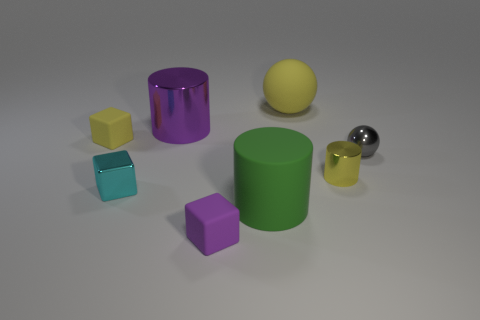Subtract all small cyan shiny cubes. How many cubes are left? 2 Subtract 1 cylinders. How many cylinders are left? 2 Subtract all purple cylinders. How many cylinders are left? 2 Subtract all brown cylinders. Subtract all gray cubes. How many cylinders are left? 3 Add 1 matte spheres. How many objects exist? 9 Subtract all balls. How many objects are left? 6 Subtract all big purple metallic blocks. Subtract all tiny cyan objects. How many objects are left? 7 Add 2 purple rubber cubes. How many purple rubber cubes are left? 3 Add 4 big purple shiny cylinders. How many big purple shiny cylinders exist? 5 Subtract 1 gray balls. How many objects are left? 7 